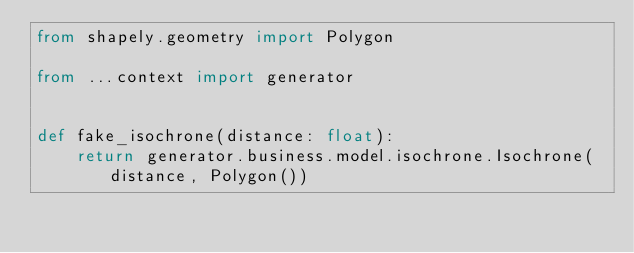Convert code to text. <code><loc_0><loc_0><loc_500><loc_500><_Python_>from shapely.geometry import Polygon

from ...context import generator


def fake_isochrone(distance: float):
    return generator.business.model.isochrone.Isochrone(distance, Polygon())
</code> 